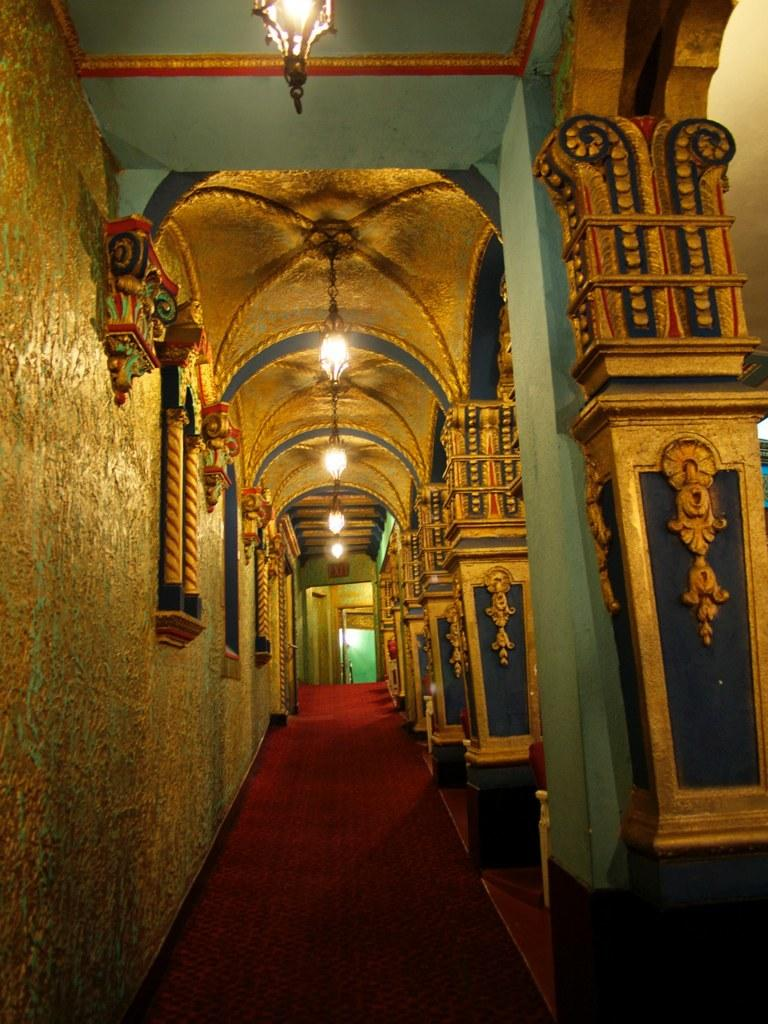What can be seen in the image that provides illumination? There are lights in the image. What architectural features are visible in the background of the image? There are pillars in the background of the image. What colors are present on the wall in the background of the image? The wall in the background has blue, yellow, and red colors. What type of flooring is present in the image? There is a red color carpet in the image. What color is the door in the background of the image? There is a green color door in the background of the image. How many houses are visible in the image? There are no houses visible in the image. Can you describe the chair that is present in the image? There is no chair present in the image. 